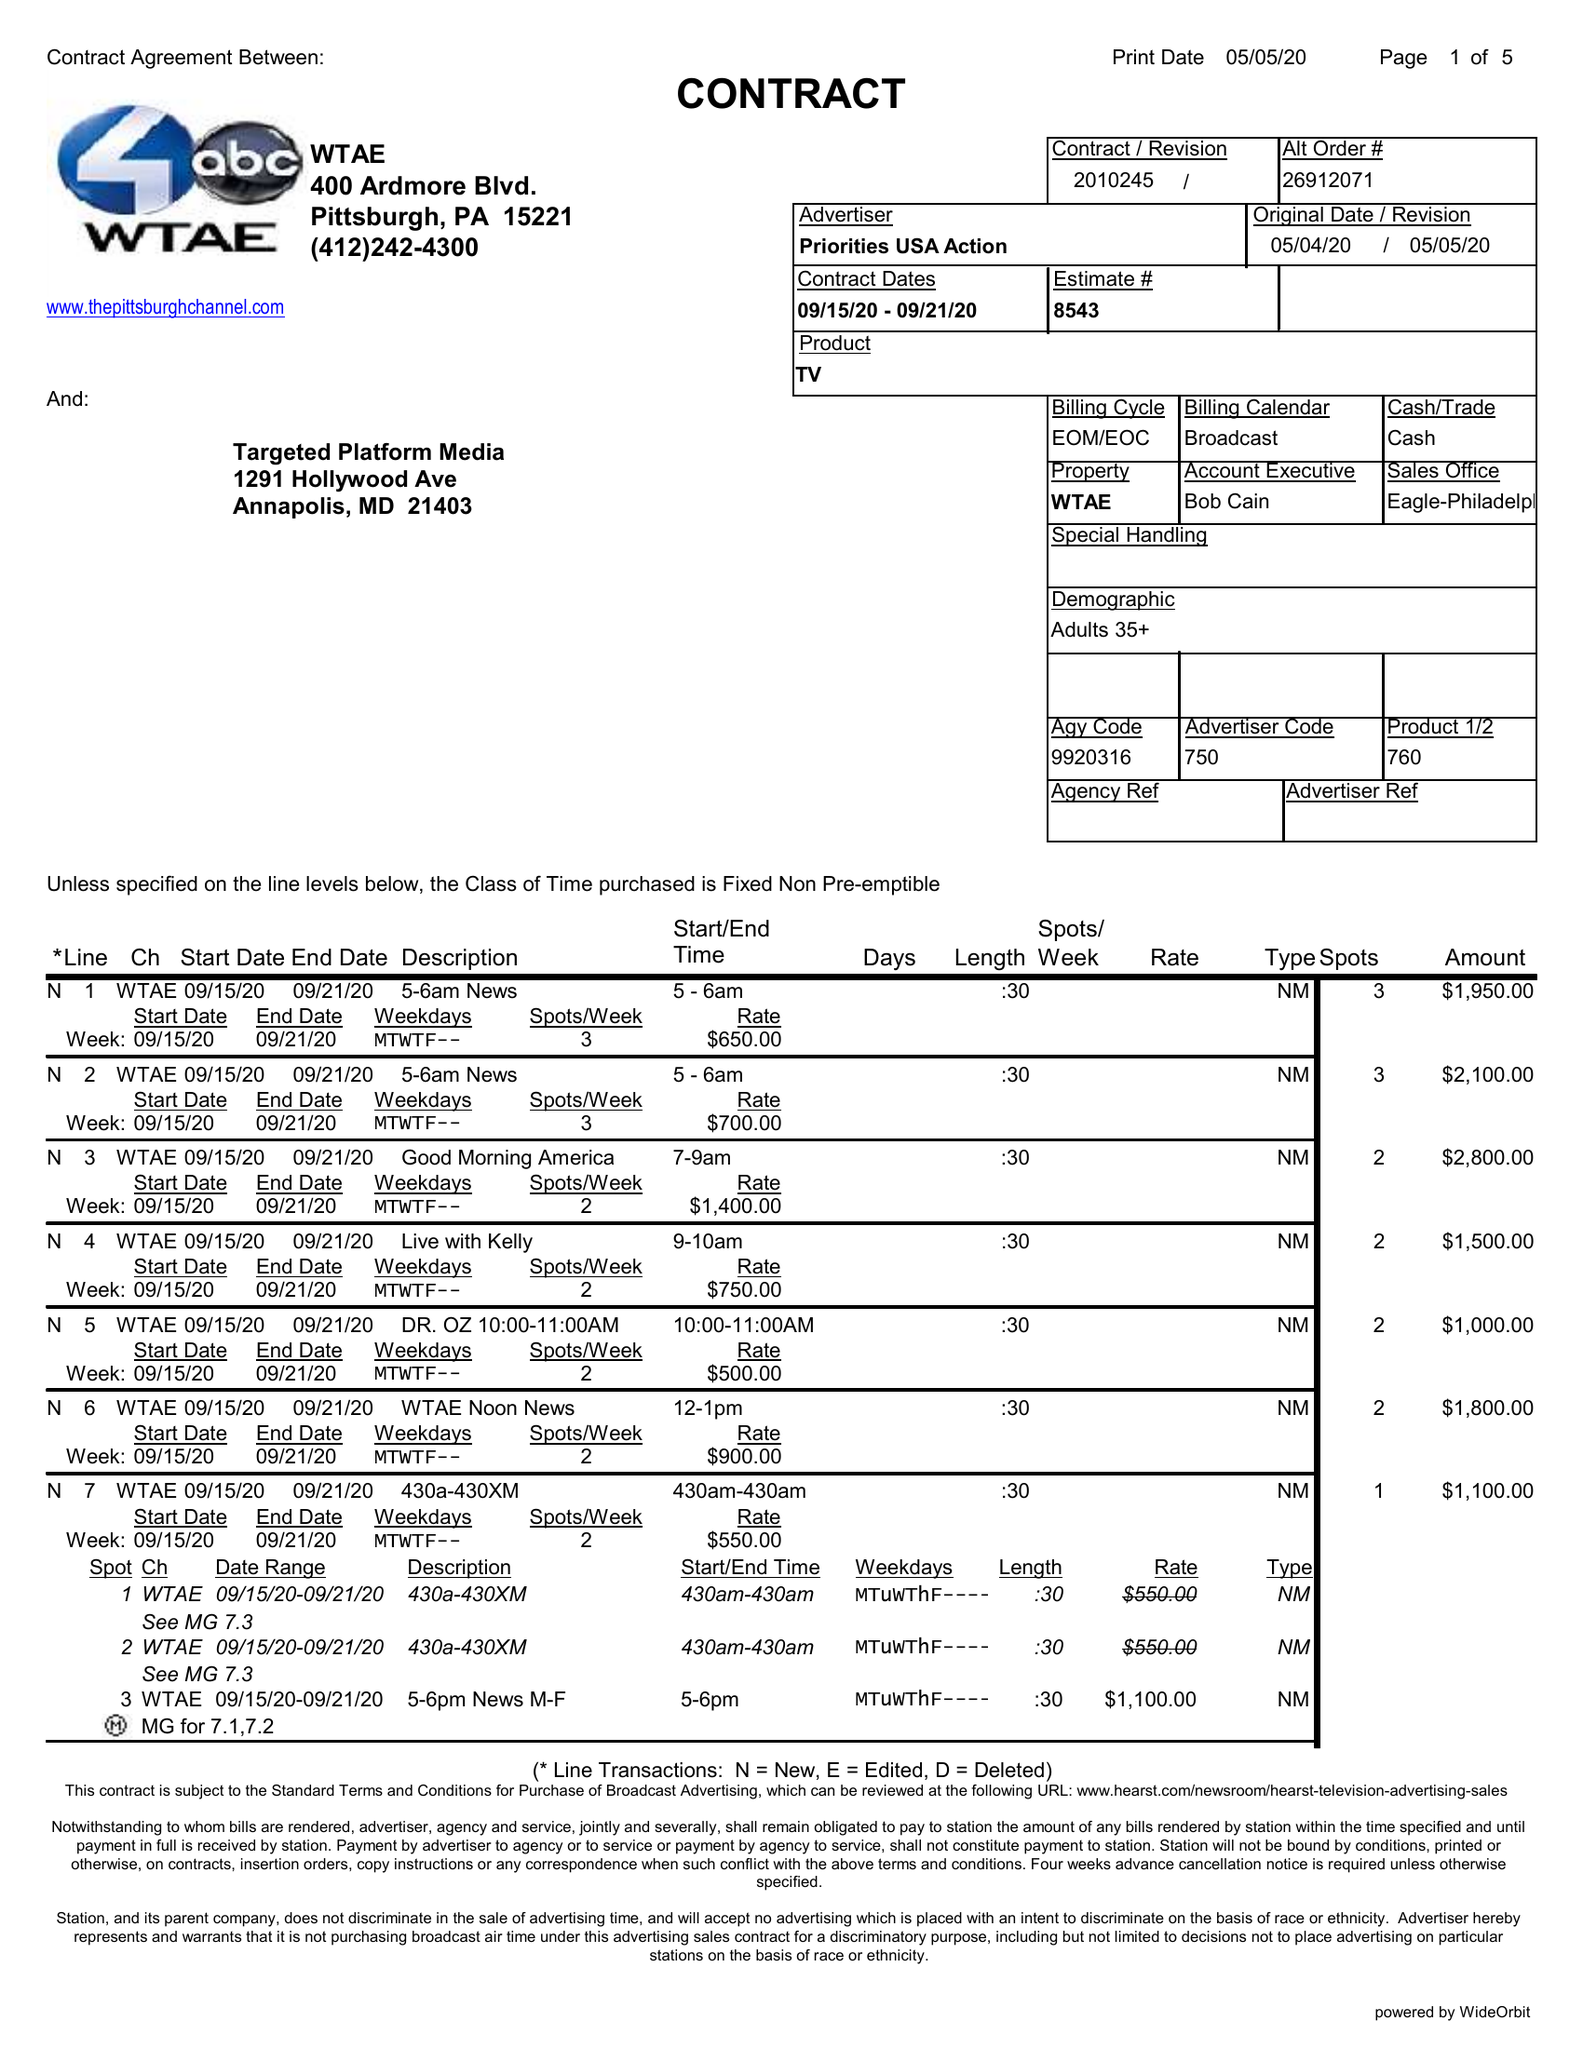What is the value for the gross_amount?
Answer the question using a single word or phrase. 48450.00 